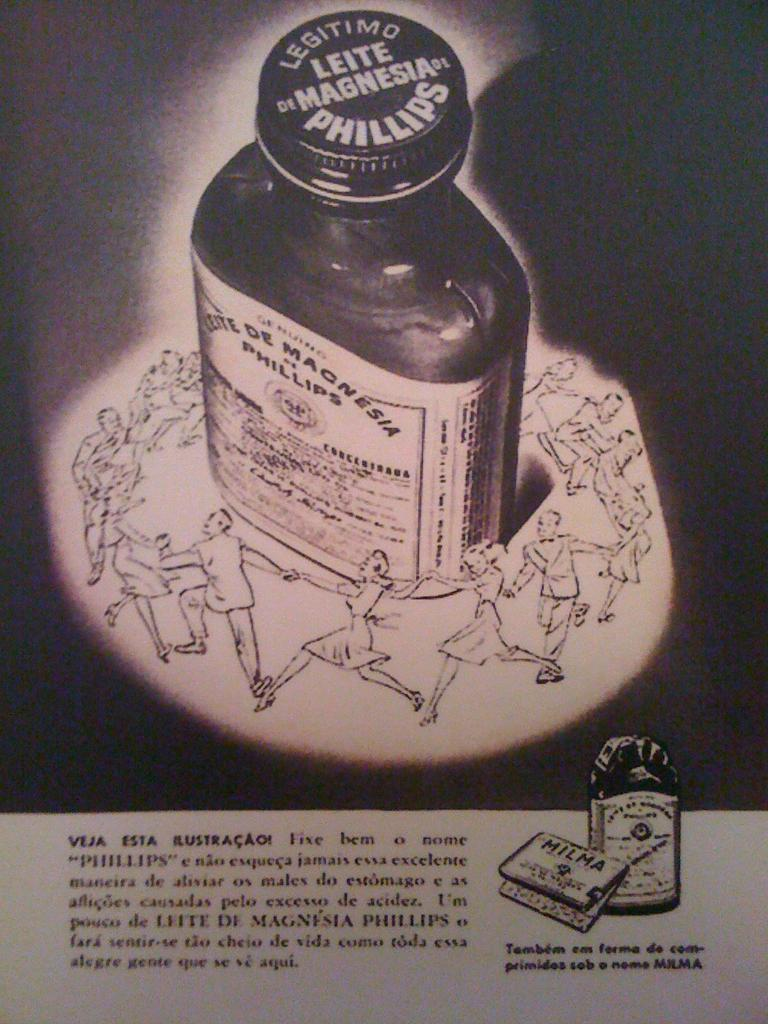<image>
Create a compact narrative representing the image presented. a paper that says 'leite magnesia legitimo phillips' on the picture of a bottle 